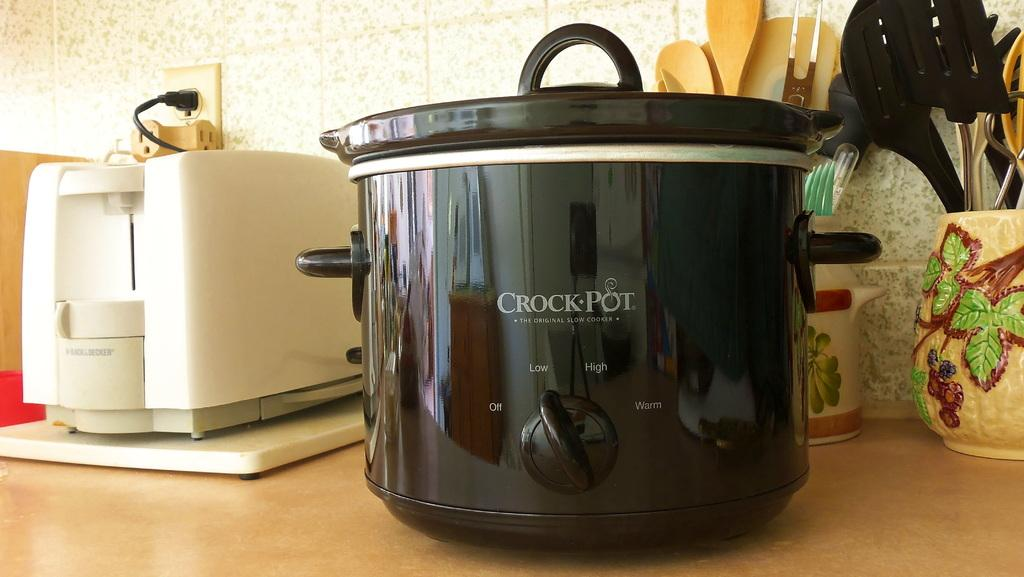<image>
Create a compact narrative representing the image presented. A big black pot with the words Crock Pot written on the front 